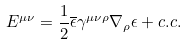<formula> <loc_0><loc_0><loc_500><loc_500>E ^ { \mu \nu } = \frac { 1 } { 2 } \overline { \epsilon } \gamma ^ { \mu \nu \rho } \nabla _ { \rho } \epsilon + c . c .</formula> 